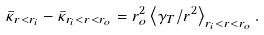Convert formula to latex. <formula><loc_0><loc_0><loc_500><loc_500>\bar { \kappa } _ { r < r _ { i } } - \bar { \kappa } _ { r _ { i } < r < r _ { o } } = r _ { o } ^ { 2 } \left \langle \gamma _ { T } / r ^ { 2 } \right \rangle _ { r _ { i } < r < r _ { o } } .</formula> 